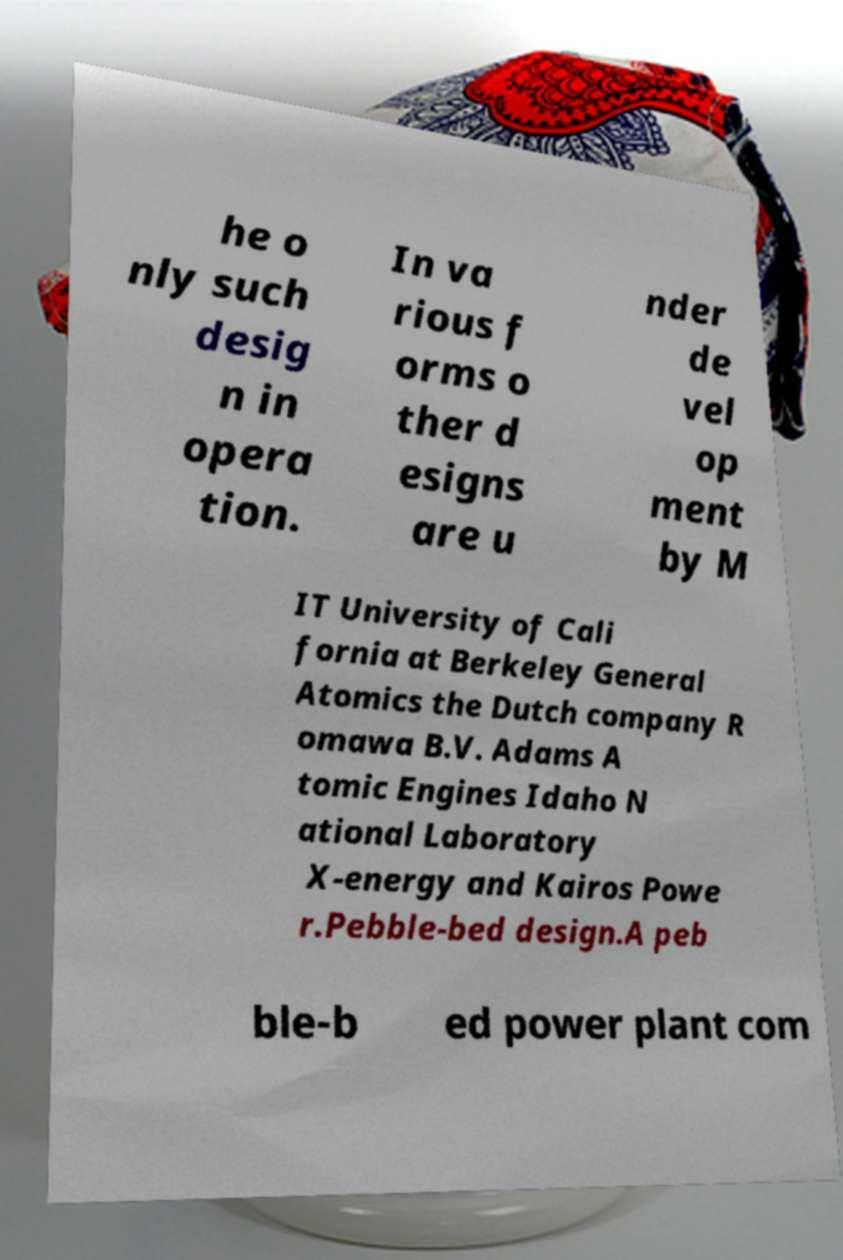Can you read and provide the text displayed in the image?This photo seems to have some interesting text. Can you extract and type it out for me? he o nly such desig n in opera tion. In va rious f orms o ther d esigns are u nder de vel op ment by M IT University of Cali fornia at Berkeley General Atomics the Dutch company R omawa B.V. Adams A tomic Engines Idaho N ational Laboratory X-energy and Kairos Powe r.Pebble-bed design.A peb ble-b ed power plant com 